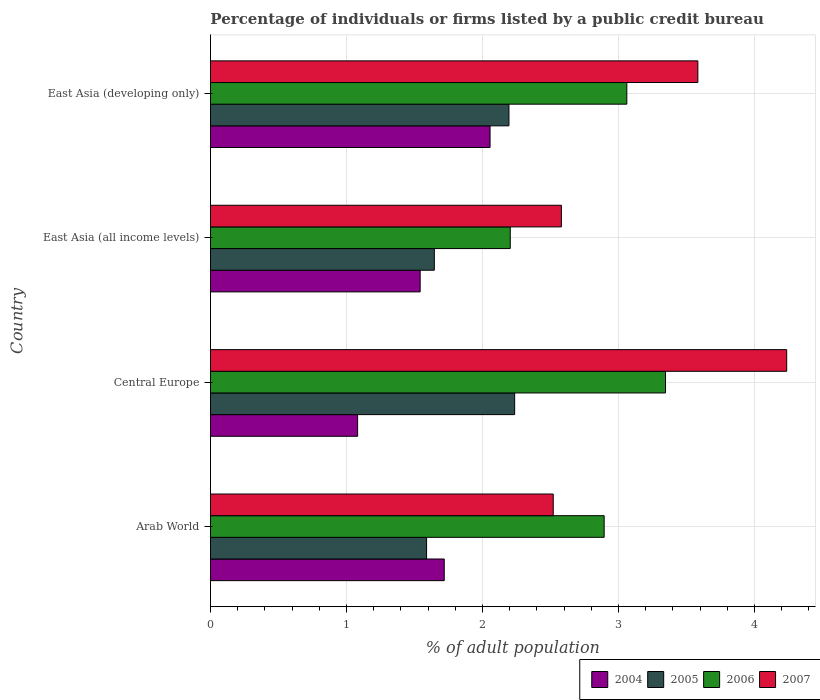Are the number of bars per tick equal to the number of legend labels?
Your response must be concise. Yes. How many bars are there on the 1st tick from the top?
Provide a succinct answer. 4. What is the label of the 1st group of bars from the top?
Give a very brief answer. East Asia (developing only). What is the percentage of population listed by a public credit bureau in 2007 in East Asia (all income levels)?
Offer a terse response. 2.58. Across all countries, what is the maximum percentage of population listed by a public credit bureau in 2004?
Keep it short and to the point. 2.06. Across all countries, what is the minimum percentage of population listed by a public credit bureau in 2004?
Your answer should be very brief. 1.08. In which country was the percentage of population listed by a public credit bureau in 2004 maximum?
Your response must be concise. East Asia (developing only). In which country was the percentage of population listed by a public credit bureau in 2007 minimum?
Your answer should be compact. Arab World. What is the total percentage of population listed by a public credit bureau in 2005 in the graph?
Give a very brief answer. 7.67. What is the difference between the percentage of population listed by a public credit bureau in 2006 in Arab World and that in Central Europe?
Offer a very short reply. -0.45. What is the difference between the percentage of population listed by a public credit bureau in 2004 in Central Europe and the percentage of population listed by a public credit bureau in 2005 in East Asia (all income levels)?
Your answer should be compact. -0.56. What is the average percentage of population listed by a public credit bureau in 2005 per country?
Offer a very short reply. 1.92. What is the difference between the percentage of population listed by a public credit bureau in 2004 and percentage of population listed by a public credit bureau in 2005 in East Asia (developing only)?
Your answer should be very brief. -0.14. What is the ratio of the percentage of population listed by a public credit bureau in 2004 in Central Europe to that in East Asia (all income levels)?
Give a very brief answer. 0.7. What is the difference between the highest and the second highest percentage of population listed by a public credit bureau in 2006?
Offer a terse response. 0.28. What is the difference between the highest and the lowest percentage of population listed by a public credit bureau in 2004?
Your answer should be compact. 0.97. Is the sum of the percentage of population listed by a public credit bureau in 2006 in East Asia (all income levels) and East Asia (developing only) greater than the maximum percentage of population listed by a public credit bureau in 2007 across all countries?
Offer a very short reply. Yes. Are all the bars in the graph horizontal?
Your response must be concise. Yes. Are the values on the major ticks of X-axis written in scientific E-notation?
Provide a succinct answer. No. Does the graph contain grids?
Give a very brief answer. Yes. Where does the legend appear in the graph?
Give a very brief answer. Bottom right. How are the legend labels stacked?
Offer a very short reply. Horizontal. What is the title of the graph?
Make the answer very short. Percentage of individuals or firms listed by a public credit bureau. What is the label or title of the X-axis?
Offer a very short reply. % of adult population. What is the % of adult population of 2004 in Arab World?
Provide a succinct answer. 1.72. What is the % of adult population of 2005 in Arab World?
Your answer should be very brief. 1.59. What is the % of adult population in 2006 in Arab World?
Ensure brevity in your answer.  2.89. What is the % of adult population of 2007 in Arab World?
Give a very brief answer. 2.52. What is the % of adult population in 2004 in Central Europe?
Offer a very short reply. 1.08. What is the % of adult population of 2005 in Central Europe?
Your answer should be very brief. 2.24. What is the % of adult population of 2006 in Central Europe?
Your response must be concise. 3.35. What is the % of adult population of 2007 in Central Europe?
Your response must be concise. 4.24. What is the % of adult population of 2004 in East Asia (all income levels)?
Offer a very short reply. 1.54. What is the % of adult population in 2005 in East Asia (all income levels)?
Ensure brevity in your answer.  1.65. What is the % of adult population of 2006 in East Asia (all income levels)?
Make the answer very short. 2.2. What is the % of adult population of 2007 in East Asia (all income levels)?
Make the answer very short. 2.58. What is the % of adult population in 2004 in East Asia (developing only)?
Give a very brief answer. 2.06. What is the % of adult population of 2005 in East Asia (developing only)?
Provide a short and direct response. 2.19. What is the % of adult population of 2006 in East Asia (developing only)?
Your answer should be compact. 3.06. What is the % of adult population of 2007 in East Asia (developing only)?
Make the answer very short. 3.58. Across all countries, what is the maximum % of adult population in 2004?
Offer a very short reply. 2.06. Across all countries, what is the maximum % of adult population of 2005?
Ensure brevity in your answer.  2.24. Across all countries, what is the maximum % of adult population of 2006?
Provide a succinct answer. 3.35. Across all countries, what is the maximum % of adult population in 2007?
Your answer should be very brief. 4.24. Across all countries, what is the minimum % of adult population of 2004?
Keep it short and to the point. 1.08. Across all countries, what is the minimum % of adult population of 2005?
Make the answer very short. 1.59. Across all countries, what is the minimum % of adult population in 2006?
Give a very brief answer. 2.2. Across all countries, what is the minimum % of adult population of 2007?
Provide a succinct answer. 2.52. What is the total % of adult population in 2004 in the graph?
Ensure brevity in your answer.  6.4. What is the total % of adult population in 2005 in the graph?
Keep it short and to the point. 7.67. What is the total % of adult population in 2006 in the graph?
Make the answer very short. 11.51. What is the total % of adult population of 2007 in the graph?
Give a very brief answer. 12.92. What is the difference between the % of adult population of 2004 in Arab World and that in Central Europe?
Offer a very short reply. 0.64. What is the difference between the % of adult population in 2005 in Arab World and that in Central Europe?
Offer a very short reply. -0.65. What is the difference between the % of adult population in 2006 in Arab World and that in Central Europe?
Provide a short and direct response. -0.45. What is the difference between the % of adult population of 2007 in Arab World and that in Central Europe?
Keep it short and to the point. -1.72. What is the difference between the % of adult population of 2004 in Arab World and that in East Asia (all income levels)?
Your response must be concise. 0.18. What is the difference between the % of adult population in 2005 in Arab World and that in East Asia (all income levels)?
Give a very brief answer. -0.06. What is the difference between the % of adult population of 2006 in Arab World and that in East Asia (all income levels)?
Offer a very short reply. 0.69. What is the difference between the % of adult population of 2007 in Arab World and that in East Asia (all income levels)?
Your response must be concise. -0.06. What is the difference between the % of adult population in 2004 in Arab World and that in East Asia (developing only)?
Your response must be concise. -0.34. What is the difference between the % of adult population of 2005 in Arab World and that in East Asia (developing only)?
Your answer should be compact. -0.61. What is the difference between the % of adult population of 2006 in Arab World and that in East Asia (developing only)?
Keep it short and to the point. -0.17. What is the difference between the % of adult population in 2007 in Arab World and that in East Asia (developing only)?
Offer a very short reply. -1.06. What is the difference between the % of adult population in 2004 in Central Europe and that in East Asia (all income levels)?
Make the answer very short. -0.46. What is the difference between the % of adult population in 2005 in Central Europe and that in East Asia (all income levels)?
Ensure brevity in your answer.  0.59. What is the difference between the % of adult population of 2006 in Central Europe and that in East Asia (all income levels)?
Your response must be concise. 1.14. What is the difference between the % of adult population of 2007 in Central Europe and that in East Asia (all income levels)?
Your answer should be compact. 1.66. What is the difference between the % of adult population in 2004 in Central Europe and that in East Asia (developing only)?
Offer a very short reply. -0.97. What is the difference between the % of adult population in 2005 in Central Europe and that in East Asia (developing only)?
Provide a short and direct response. 0.04. What is the difference between the % of adult population of 2006 in Central Europe and that in East Asia (developing only)?
Provide a short and direct response. 0.28. What is the difference between the % of adult population of 2007 in Central Europe and that in East Asia (developing only)?
Keep it short and to the point. 0.65. What is the difference between the % of adult population in 2004 in East Asia (all income levels) and that in East Asia (developing only)?
Your answer should be very brief. -0.51. What is the difference between the % of adult population in 2005 in East Asia (all income levels) and that in East Asia (developing only)?
Provide a succinct answer. -0.55. What is the difference between the % of adult population in 2006 in East Asia (all income levels) and that in East Asia (developing only)?
Offer a very short reply. -0.86. What is the difference between the % of adult population of 2007 in East Asia (all income levels) and that in East Asia (developing only)?
Give a very brief answer. -1. What is the difference between the % of adult population of 2004 in Arab World and the % of adult population of 2005 in Central Europe?
Provide a succinct answer. -0.52. What is the difference between the % of adult population of 2004 in Arab World and the % of adult population of 2006 in Central Europe?
Provide a short and direct response. -1.63. What is the difference between the % of adult population in 2004 in Arab World and the % of adult population in 2007 in Central Europe?
Ensure brevity in your answer.  -2.52. What is the difference between the % of adult population in 2005 in Arab World and the % of adult population in 2006 in Central Europe?
Give a very brief answer. -1.76. What is the difference between the % of adult population in 2005 in Arab World and the % of adult population in 2007 in Central Europe?
Your response must be concise. -2.65. What is the difference between the % of adult population of 2006 in Arab World and the % of adult population of 2007 in Central Europe?
Your response must be concise. -1.34. What is the difference between the % of adult population of 2004 in Arab World and the % of adult population of 2005 in East Asia (all income levels)?
Keep it short and to the point. 0.07. What is the difference between the % of adult population in 2004 in Arab World and the % of adult population in 2006 in East Asia (all income levels)?
Your answer should be very brief. -0.49. What is the difference between the % of adult population in 2004 in Arab World and the % of adult population in 2007 in East Asia (all income levels)?
Your answer should be very brief. -0.86. What is the difference between the % of adult population in 2005 in Arab World and the % of adult population in 2006 in East Asia (all income levels)?
Provide a succinct answer. -0.62. What is the difference between the % of adult population in 2005 in Arab World and the % of adult population in 2007 in East Asia (all income levels)?
Ensure brevity in your answer.  -0.99. What is the difference between the % of adult population of 2006 in Arab World and the % of adult population of 2007 in East Asia (all income levels)?
Offer a terse response. 0.31. What is the difference between the % of adult population of 2004 in Arab World and the % of adult population of 2005 in East Asia (developing only)?
Your answer should be very brief. -0.48. What is the difference between the % of adult population in 2004 in Arab World and the % of adult population in 2006 in East Asia (developing only)?
Provide a succinct answer. -1.34. What is the difference between the % of adult population in 2004 in Arab World and the % of adult population in 2007 in East Asia (developing only)?
Your answer should be very brief. -1.86. What is the difference between the % of adult population of 2005 in Arab World and the % of adult population of 2006 in East Asia (developing only)?
Provide a short and direct response. -1.47. What is the difference between the % of adult population of 2005 in Arab World and the % of adult population of 2007 in East Asia (developing only)?
Keep it short and to the point. -1.99. What is the difference between the % of adult population of 2006 in Arab World and the % of adult population of 2007 in East Asia (developing only)?
Your response must be concise. -0.69. What is the difference between the % of adult population of 2004 in Central Europe and the % of adult population of 2005 in East Asia (all income levels)?
Give a very brief answer. -0.56. What is the difference between the % of adult population in 2004 in Central Europe and the % of adult population in 2006 in East Asia (all income levels)?
Give a very brief answer. -1.12. What is the difference between the % of adult population of 2004 in Central Europe and the % of adult population of 2007 in East Asia (all income levels)?
Ensure brevity in your answer.  -1.5. What is the difference between the % of adult population in 2005 in Central Europe and the % of adult population in 2006 in East Asia (all income levels)?
Provide a succinct answer. 0.03. What is the difference between the % of adult population in 2005 in Central Europe and the % of adult population in 2007 in East Asia (all income levels)?
Ensure brevity in your answer.  -0.34. What is the difference between the % of adult population of 2006 in Central Europe and the % of adult population of 2007 in East Asia (all income levels)?
Keep it short and to the point. 0.77. What is the difference between the % of adult population in 2004 in Central Europe and the % of adult population in 2005 in East Asia (developing only)?
Offer a terse response. -1.11. What is the difference between the % of adult population of 2004 in Central Europe and the % of adult population of 2006 in East Asia (developing only)?
Your response must be concise. -1.98. What is the difference between the % of adult population of 2004 in Central Europe and the % of adult population of 2007 in East Asia (developing only)?
Your answer should be compact. -2.5. What is the difference between the % of adult population in 2005 in Central Europe and the % of adult population in 2006 in East Asia (developing only)?
Your response must be concise. -0.82. What is the difference between the % of adult population in 2005 in Central Europe and the % of adult population in 2007 in East Asia (developing only)?
Offer a terse response. -1.35. What is the difference between the % of adult population of 2006 in Central Europe and the % of adult population of 2007 in East Asia (developing only)?
Ensure brevity in your answer.  -0.24. What is the difference between the % of adult population in 2004 in East Asia (all income levels) and the % of adult population in 2005 in East Asia (developing only)?
Provide a succinct answer. -0.65. What is the difference between the % of adult population of 2004 in East Asia (all income levels) and the % of adult population of 2006 in East Asia (developing only)?
Give a very brief answer. -1.52. What is the difference between the % of adult population of 2004 in East Asia (all income levels) and the % of adult population of 2007 in East Asia (developing only)?
Ensure brevity in your answer.  -2.04. What is the difference between the % of adult population in 2005 in East Asia (all income levels) and the % of adult population in 2006 in East Asia (developing only)?
Make the answer very short. -1.42. What is the difference between the % of adult population in 2005 in East Asia (all income levels) and the % of adult population in 2007 in East Asia (developing only)?
Your answer should be very brief. -1.94. What is the difference between the % of adult population of 2006 in East Asia (all income levels) and the % of adult population of 2007 in East Asia (developing only)?
Ensure brevity in your answer.  -1.38. What is the average % of adult population of 2004 per country?
Give a very brief answer. 1.6. What is the average % of adult population in 2005 per country?
Offer a terse response. 1.92. What is the average % of adult population of 2006 per country?
Your answer should be very brief. 2.88. What is the average % of adult population in 2007 per country?
Provide a short and direct response. 3.23. What is the difference between the % of adult population of 2004 and % of adult population of 2005 in Arab World?
Ensure brevity in your answer.  0.13. What is the difference between the % of adult population of 2004 and % of adult population of 2006 in Arab World?
Give a very brief answer. -1.18. What is the difference between the % of adult population of 2004 and % of adult population of 2007 in Arab World?
Provide a short and direct response. -0.8. What is the difference between the % of adult population in 2005 and % of adult population in 2006 in Arab World?
Offer a terse response. -1.31. What is the difference between the % of adult population in 2005 and % of adult population in 2007 in Arab World?
Your answer should be compact. -0.93. What is the difference between the % of adult population of 2006 and % of adult population of 2007 in Arab World?
Provide a short and direct response. 0.37. What is the difference between the % of adult population of 2004 and % of adult population of 2005 in Central Europe?
Offer a terse response. -1.15. What is the difference between the % of adult population of 2004 and % of adult population of 2006 in Central Europe?
Make the answer very short. -2.26. What is the difference between the % of adult population in 2004 and % of adult population in 2007 in Central Europe?
Offer a very short reply. -3.15. What is the difference between the % of adult population of 2005 and % of adult population of 2006 in Central Europe?
Provide a succinct answer. -1.11. What is the difference between the % of adult population of 2006 and % of adult population of 2007 in Central Europe?
Provide a succinct answer. -0.89. What is the difference between the % of adult population of 2004 and % of adult population of 2005 in East Asia (all income levels)?
Keep it short and to the point. -0.1. What is the difference between the % of adult population in 2004 and % of adult population in 2006 in East Asia (all income levels)?
Ensure brevity in your answer.  -0.66. What is the difference between the % of adult population in 2004 and % of adult population in 2007 in East Asia (all income levels)?
Your answer should be compact. -1.04. What is the difference between the % of adult population of 2005 and % of adult population of 2006 in East Asia (all income levels)?
Give a very brief answer. -0.56. What is the difference between the % of adult population in 2005 and % of adult population in 2007 in East Asia (all income levels)?
Provide a succinct answer. -0.93. What is the difference between the % of adult population in 2006 and % of adult population in 2007 in East Asia (all income levels)?
Offer a very short reply. -0.38. What is the difference between the % of adult population of 2004 and % of adult population of 2005 in East Asia (developing only)?
Ensure brevity in your answer.  -0.14. What is the difference between the % of adult population of 2004 and % of adult population of 2006 in East Asia (developing only)?
Provide a succinct answer. -1.01. What is the difference between the % of adult population in 2004 and % of adult population in 2007 in East Asia (developing only)?
Your answer should be very brief. -1.53. What is the difference between the % of adult population in 2005 and % of adult population in 2006 in East Asia (developing only)?
Make the answer very short. -0.87. What is the difference between the % of adult population in 2005 and % of adult population in 2007 in East Asia (developing only)?
Give a very brief answer. -1.39. What is the difference between the % of adult population of 2006 and % of adult population of 2007 in East Asia (developing only)?
Make the answer very short. -0.52. What is the ratio of the % of adult population of 2004 in Arab World to that in Central Europe?
Give a very brief answer. 1.59. What is the ratio of the % of adult population in 2005 in Arab World to that in Central Europe?
Your answer should be compact. 0.71. What is the ratio of the % of adult population of 2006 in Arab World to that in Central Europe?
Make the answer very short. 0.87. What is the ratio of the % of adult population of 2007 in Arab World to that in Central Europe?
Provide a succinct answer. 0.59. What is the ratio of the % of adult population in 2004 in Arab World to that in East Asia (all income levels)?
Your answer should be very brief. 1.11. What is the ratio of the % of adult population of 2005 in Arab World to that in East Asia (all income levels)?
Your response must be concise. 0.97. What is the ratio of the % of adult population of 2006 in Arab World to that in East Asia (all income levels)?
Give a very brief answer. 1.31. What is the ratio of the % of adult population in 2007 in Arab World to that in East Asia (all income levels)?
Offer a very short reply. 0.98. What is the ratio of the % of adult population of 2004 in Arab World to that in East Asia (developing only)?
Make the answer very short. 0.84. What is the ratio of the % of adult population of 2005 in Arab World to that in East Asia (developing only)?
Keep it short and to the point. 0.72. What is the ratio of the % of adult population of 2006 in Arab World to that in East Asia (developing only)?
Ensure brevity in your answer.  0.95. What is the ratio of the % of adult population of 2007 in Arab World to that in East Asia (developing only)?
Provide a short and direct response. 0.7. What is the ratio of the % of adult population in 2004 in Central Europe to that in East Asia (all income levels)?
Make the answer very short. 0.7. What is the ratio of the % of adult population in 2005 in Central Europe to that in East Asia (all income levels)?
Your answer should be compact. 1.36. What is the ratio of the % of adult population of 2006 in Central Europe to that in East Asia (all income levels)?
Your answer should be compact. 1.52. What is the ratio of the % of adult population in 2007 in Central Europe to that in East Asia (all income levels)?
Offer a terse response. 1.64. What is the ratio of the % of adult population of 2004 in Central Europe to that in East Asia (developing only)?
Offer a very short reply. 0.53. What is the ratio of the % of adult population of 2005 in Central Europe to that in East Asia (developing only)?
Make the answer very short. 1.02. What is the ratio of the % of adult population of 2006 in Central Europe to that in East Asia (developing only)?
Keep it short and to the point. 1.09. What is the ratio of the % of adult population of 2007 in Central Europe to that in East Asia (developing only)?
Provide a short and direct response. 1.18. What is the ratio of the % of adult population of 2006 in East Asia (all income levels) to that in East Asia (developing only)?
Your answer should be very brief. 0.72. What is the ratio of the % of adult population of 2007 in East Asia (all income levels) to that in East Asia (developing only)?
Provide a succinct answer. 0.72. What is the difference between the highest and the second highest % of adult population in 2004?
Keep it short and to the point. 0.34. What is the difference between the highest and the second highest % of adult population of 2005?
Your answer should be very brief. 0.04. What is the difference between the highest and the second highest % of adult population of 2006?
Ensure brevity in your answer.  0.28. What is the difference between the highest and the second highest % of adult population in 2007?
Your answer should be compact. 0.65. What is the difference between the highest and the lowest % of adult population in 2004?
Offer a terse response. 0.97. What is the difference between the highest and the lowest % of adult population of 2005?
Ensure brevity in your answer.  0.65. What is the difference between the highest and the lowest % of adult population of 2006?
Your answer should be very brief. 1.14. What is the difference between the highest and the lowest % of adult population in 2007?
Make the answer very short. 1.72. 